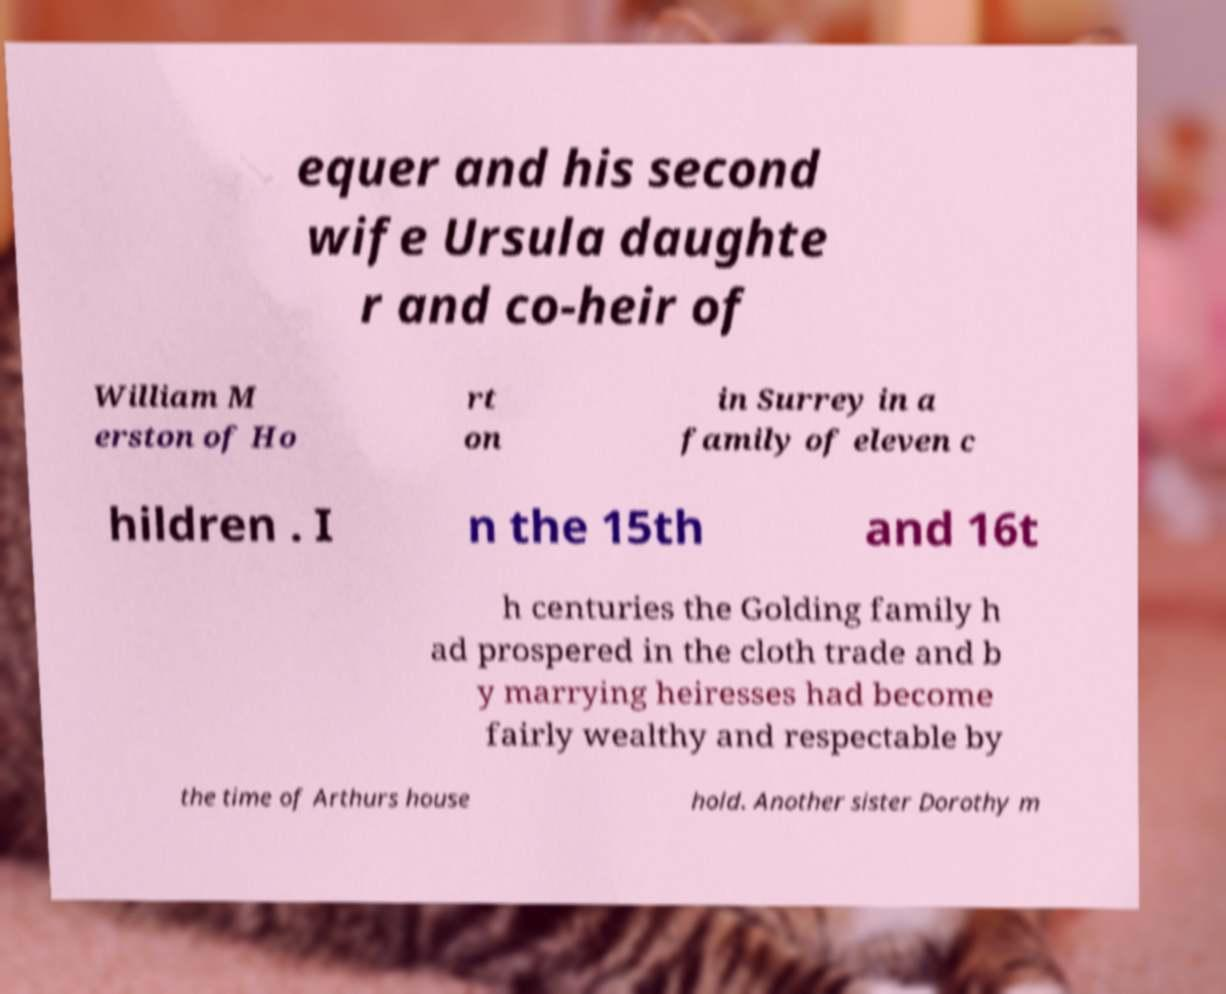Could you assist in decoding the text presented in this image and type it out clearly? equer and his second wife Ursula daughte r and co-heir of William M erston of Ho rt on in Surrey in a family of eleven c hildren . I n the 15th and 16t h centuries the Golding family h ad prospered in the cloth trade and b y marrying heiresses had become fairly wealthy and respectable by the time of Arthurs house hold. Another sister Dorothy m 